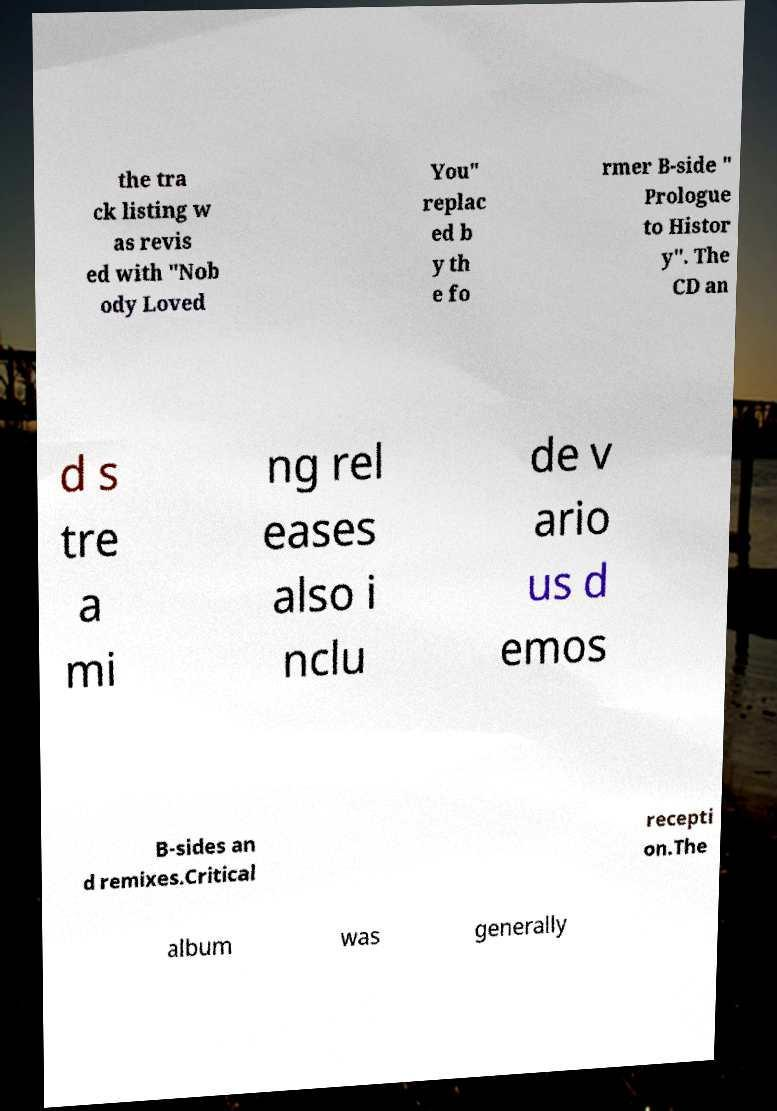For documentation purposes, I need the text within this image transcribed. Could you provide that? the tra ck listing w as revis ed with "Nob ody Loved You" replac ed b y th e fo rmer B-side " Prologue to Histor y". The CD an d s tre a mi ng rel eases also i nclu de v ario us d emos B-sides an d remixes.Critical recepti on.The album was generally 